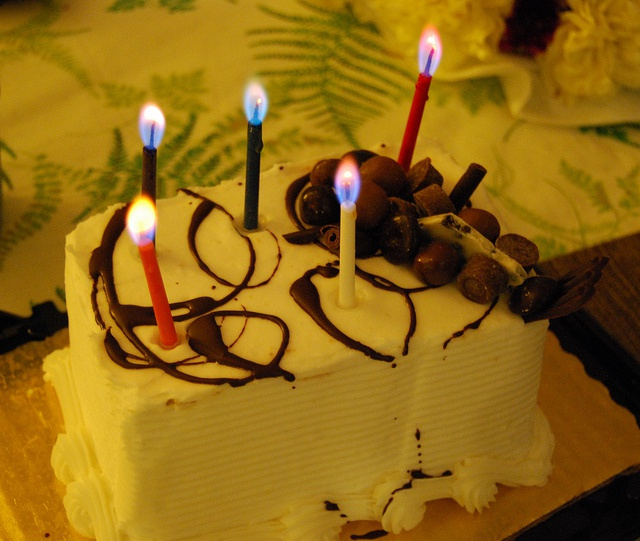Describe the objects in this image and their specific colors. I can see a cake in black, olive, and orange tones in this image. 